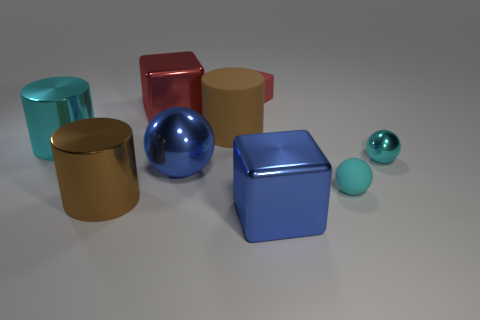There is a cyan metallic thing that is to the left of the cyan metal sphere; is its size the same as the sphere that is to the left of the tiny cube?
Your answer should be very brief. Yes. There is a metal object that is behind the rubber cylinder; what shape is it?
Your answer should be compact. Cube. There is another cyan object that is the same shape as the small cyan shiny thing; what material is it?
Ensure brevity in your answer.  Rubber. Do the blue object on the left side of the blue cube and the large cyan metal object have the same size?
Keep it short and to the point. Yes. There is a small cyan rubber object; how many blue shiny blocks are right of it?
Give a very brief answer. 0. Are there fewer matte spheres that are behind the red shiny object than brown cylinders that are in front of the tiny rubber cube?
Offer a very short reply. Yes. What number of tiny green metallic blocks are there?
Provide a short and direct response. 0. There is a metallic sphere to the right of the blue shiny block; what is its color?
Make the answer very short. Cyan. What size is the brown matte thing?
Your answer should be compact. Large. There is a small cube; is it the same color as the big shiny block that is to the left of the big blue shiny cube?
Keep it short and to the point. Yes. 